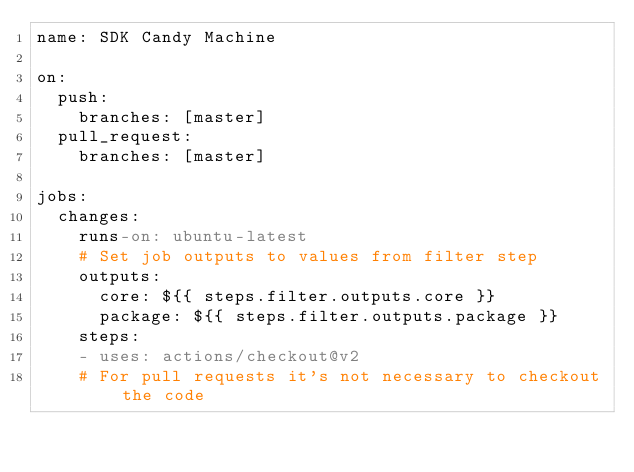Convert code to text. <code><loc_0><loc_0><loc_500><loc_500><_YAML_>name: SDK Candy Machine

on:
  push:
    branches: [master]
  pull_request:
    branches: [master]

jobs:
  changes:
    runs-on: ubuntu-latest
    # Set job outputs to values from filter step
    outputs:
      core: ${{ steps.filter.outputs.core }}
      package: ${{ steps.filter.outputs.package }}
    steps:
    - uses: actions/checkout@v2
    # For pull requests it's not necessary to checkout the code</code> 